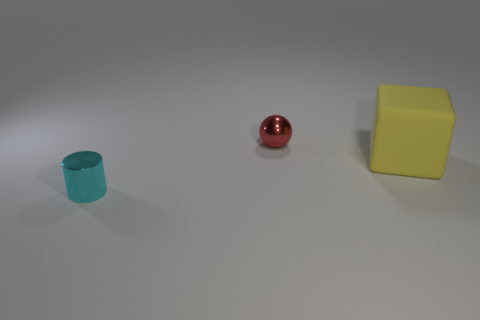There is a object behind the yellow object; what is its shape? sphere 